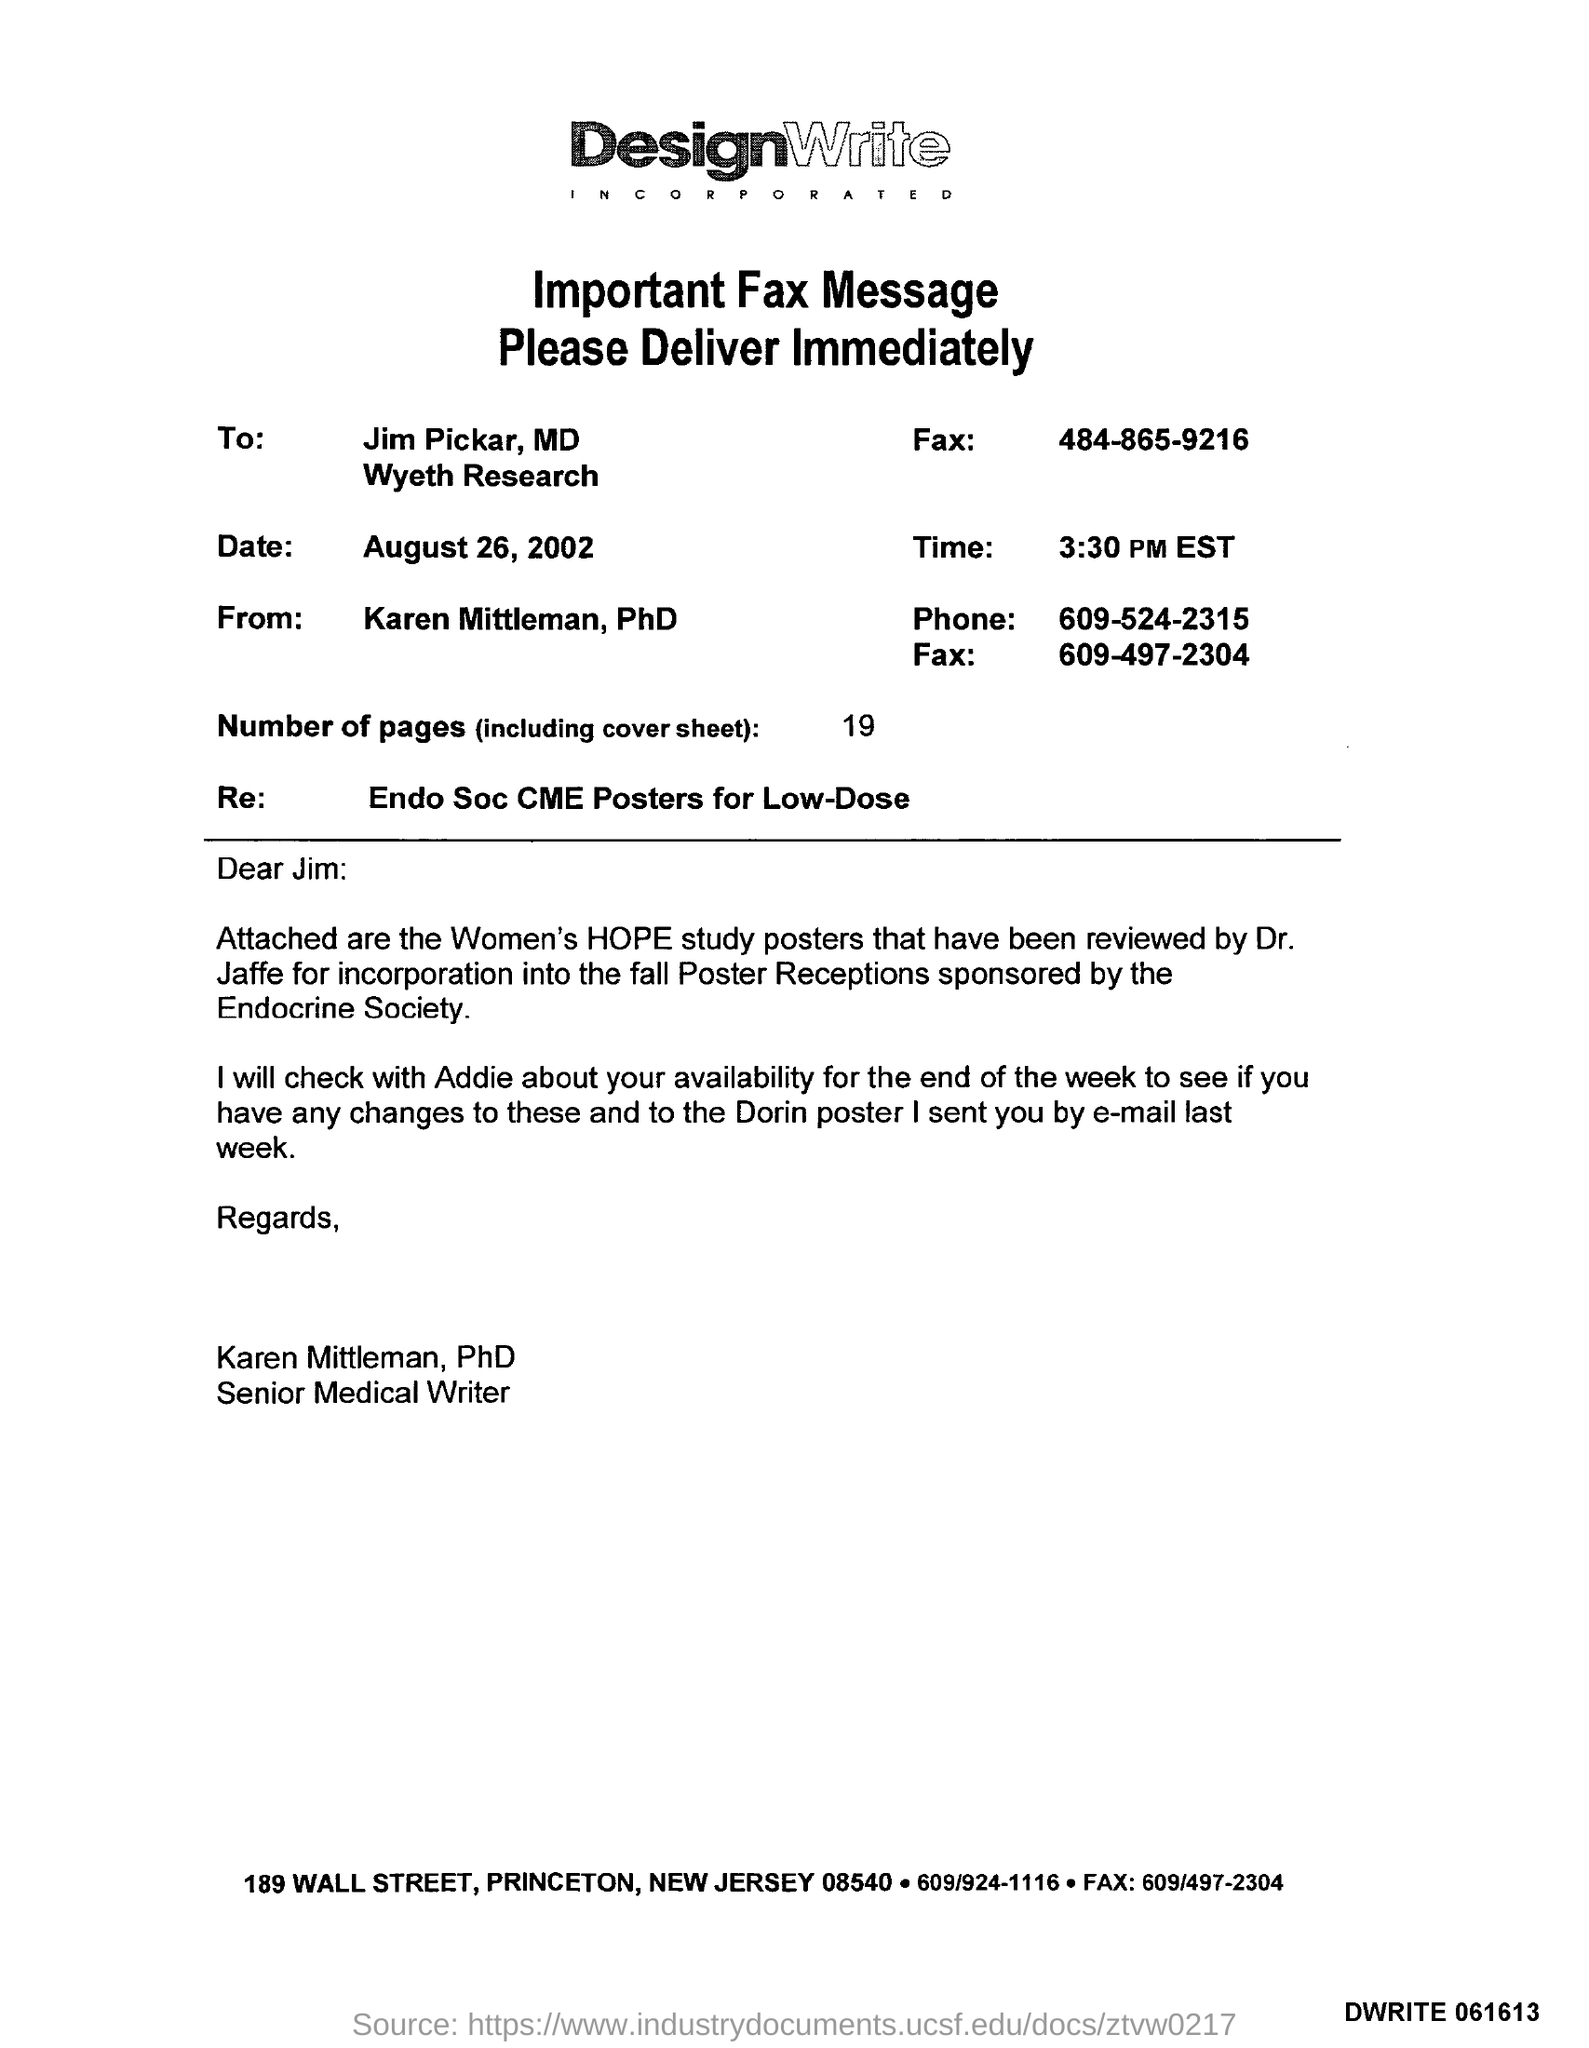What is the attachment along with this letter?
Your response must be concise. Women\s HOPE study posters. What is the salutation of this letter?
Your answer should be very brief. Dear Jim. What is total number of sheets including cover sheet?
Provide a short and direct response. 19. 